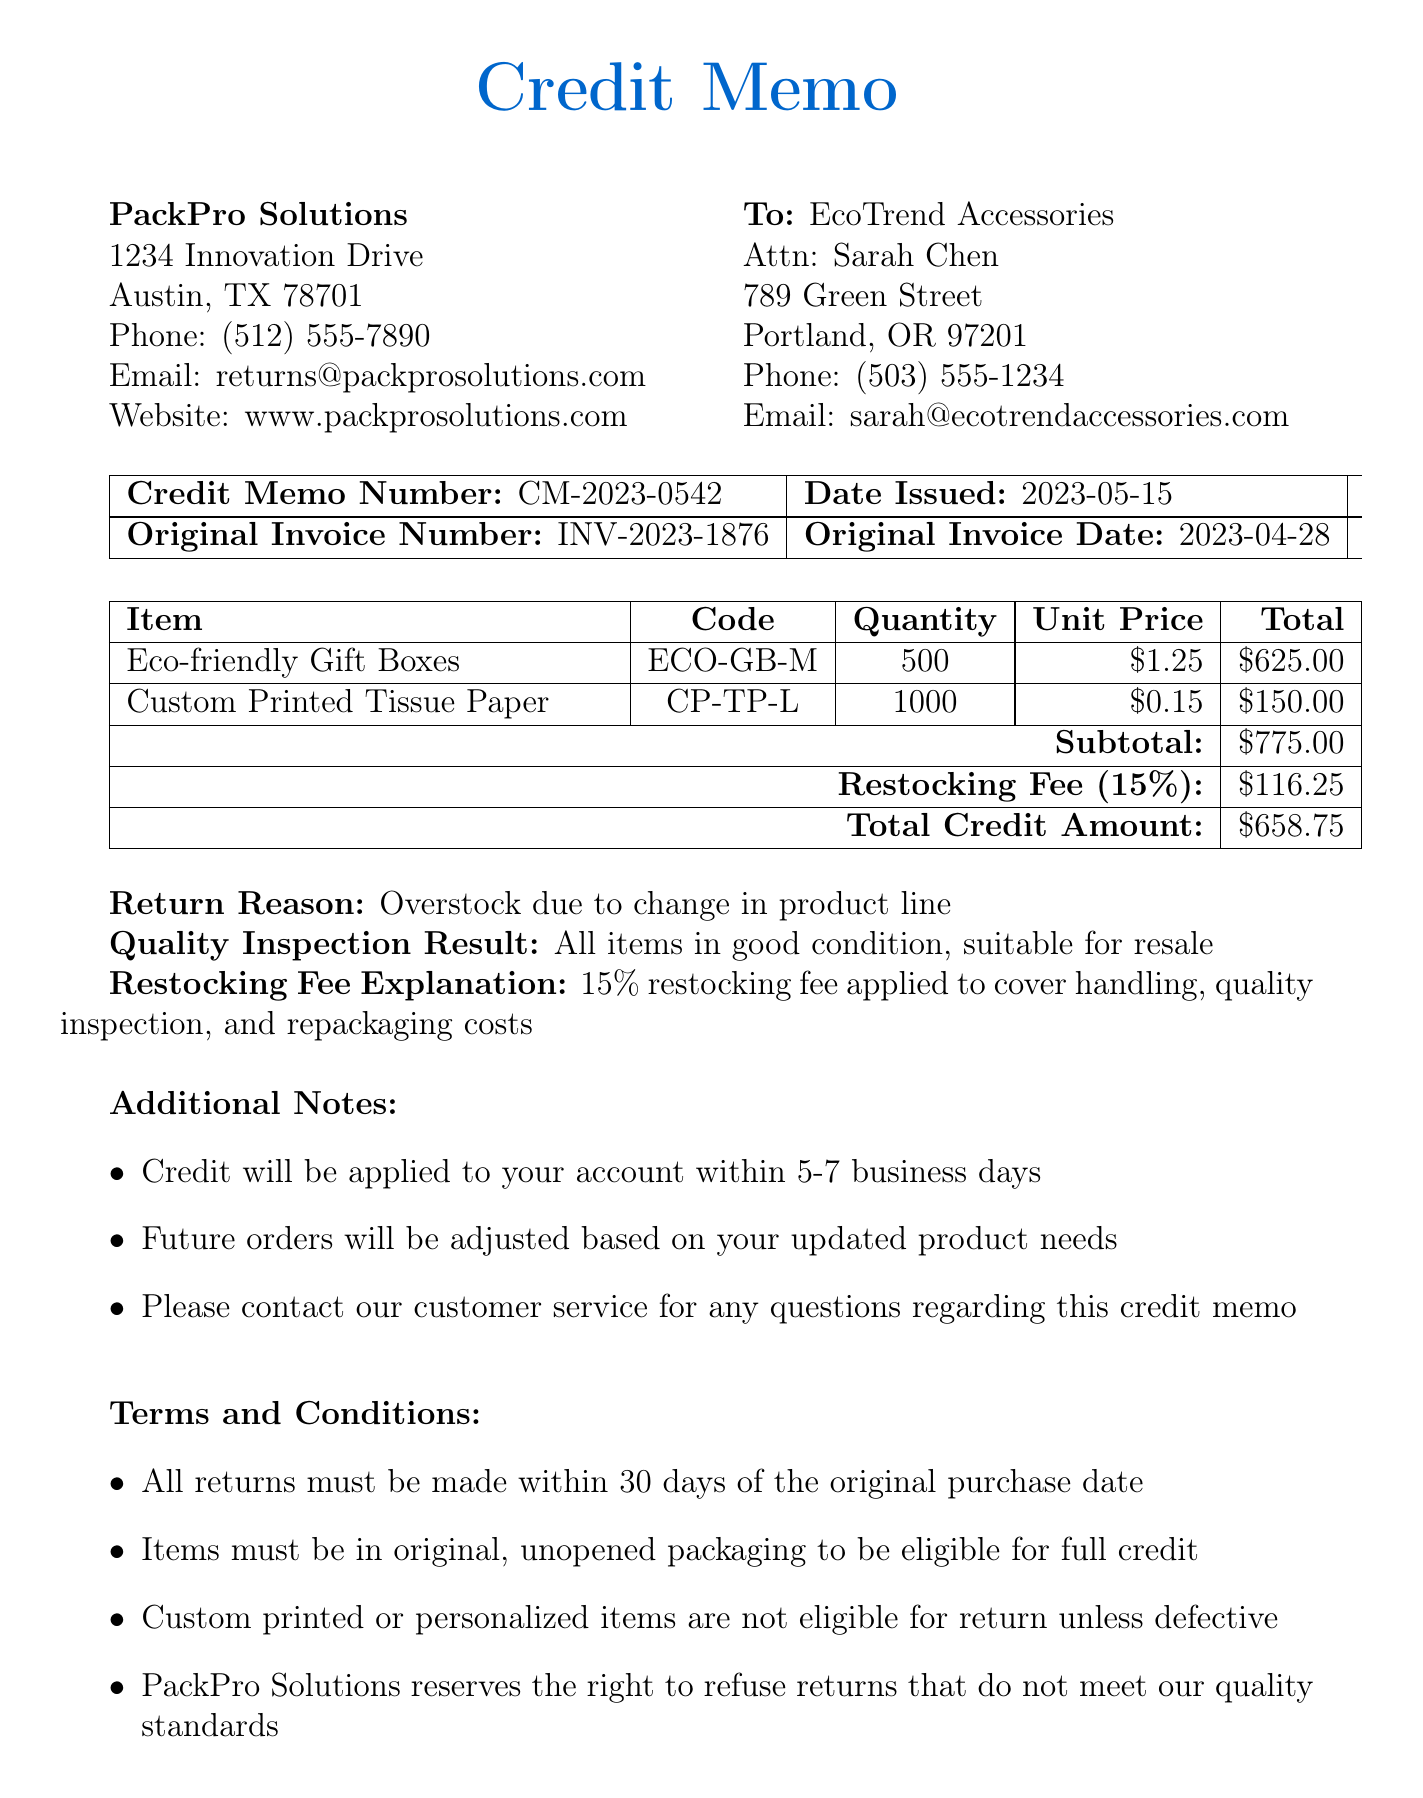what is the memo number? The memo number is a specific identifier for the credit memo found in the document.
Answer: CM-2023-0542 what is the date issued? The date issued specifies when the credit memo was created.
Answer: 2023-05-15 what is the reason for the return? The reason for the return explains why the items were sent back.
Answer: Overstock due to change in product line how much is the restocking fee? The restocking fee is the amount charged for returning items, based on the guidelines provided.
Answer: 116.25 what items were returned? This question identifies the products that were included in the return process.
Answer: Eco-friendly Gift Boxes, Custom Printed Tissue Paper what is the total credit amount? This question asks for the final amount credited after deductions, which includes the subtotal and the restocking fee.
Answer: 658.75 who authorized the credit memo? The authorized person is the individual responsible for validating the credit memo's issuance.
Answer: Michael Rodriguez what percentage is the restocking fee? This question looks for the proportion charged for restocking returned items.
Answer: 15 what is the quality inspection result? The quality inspection result states the condition of the returned items after inspection.
Answer: All items in good condition, suitable for resale 